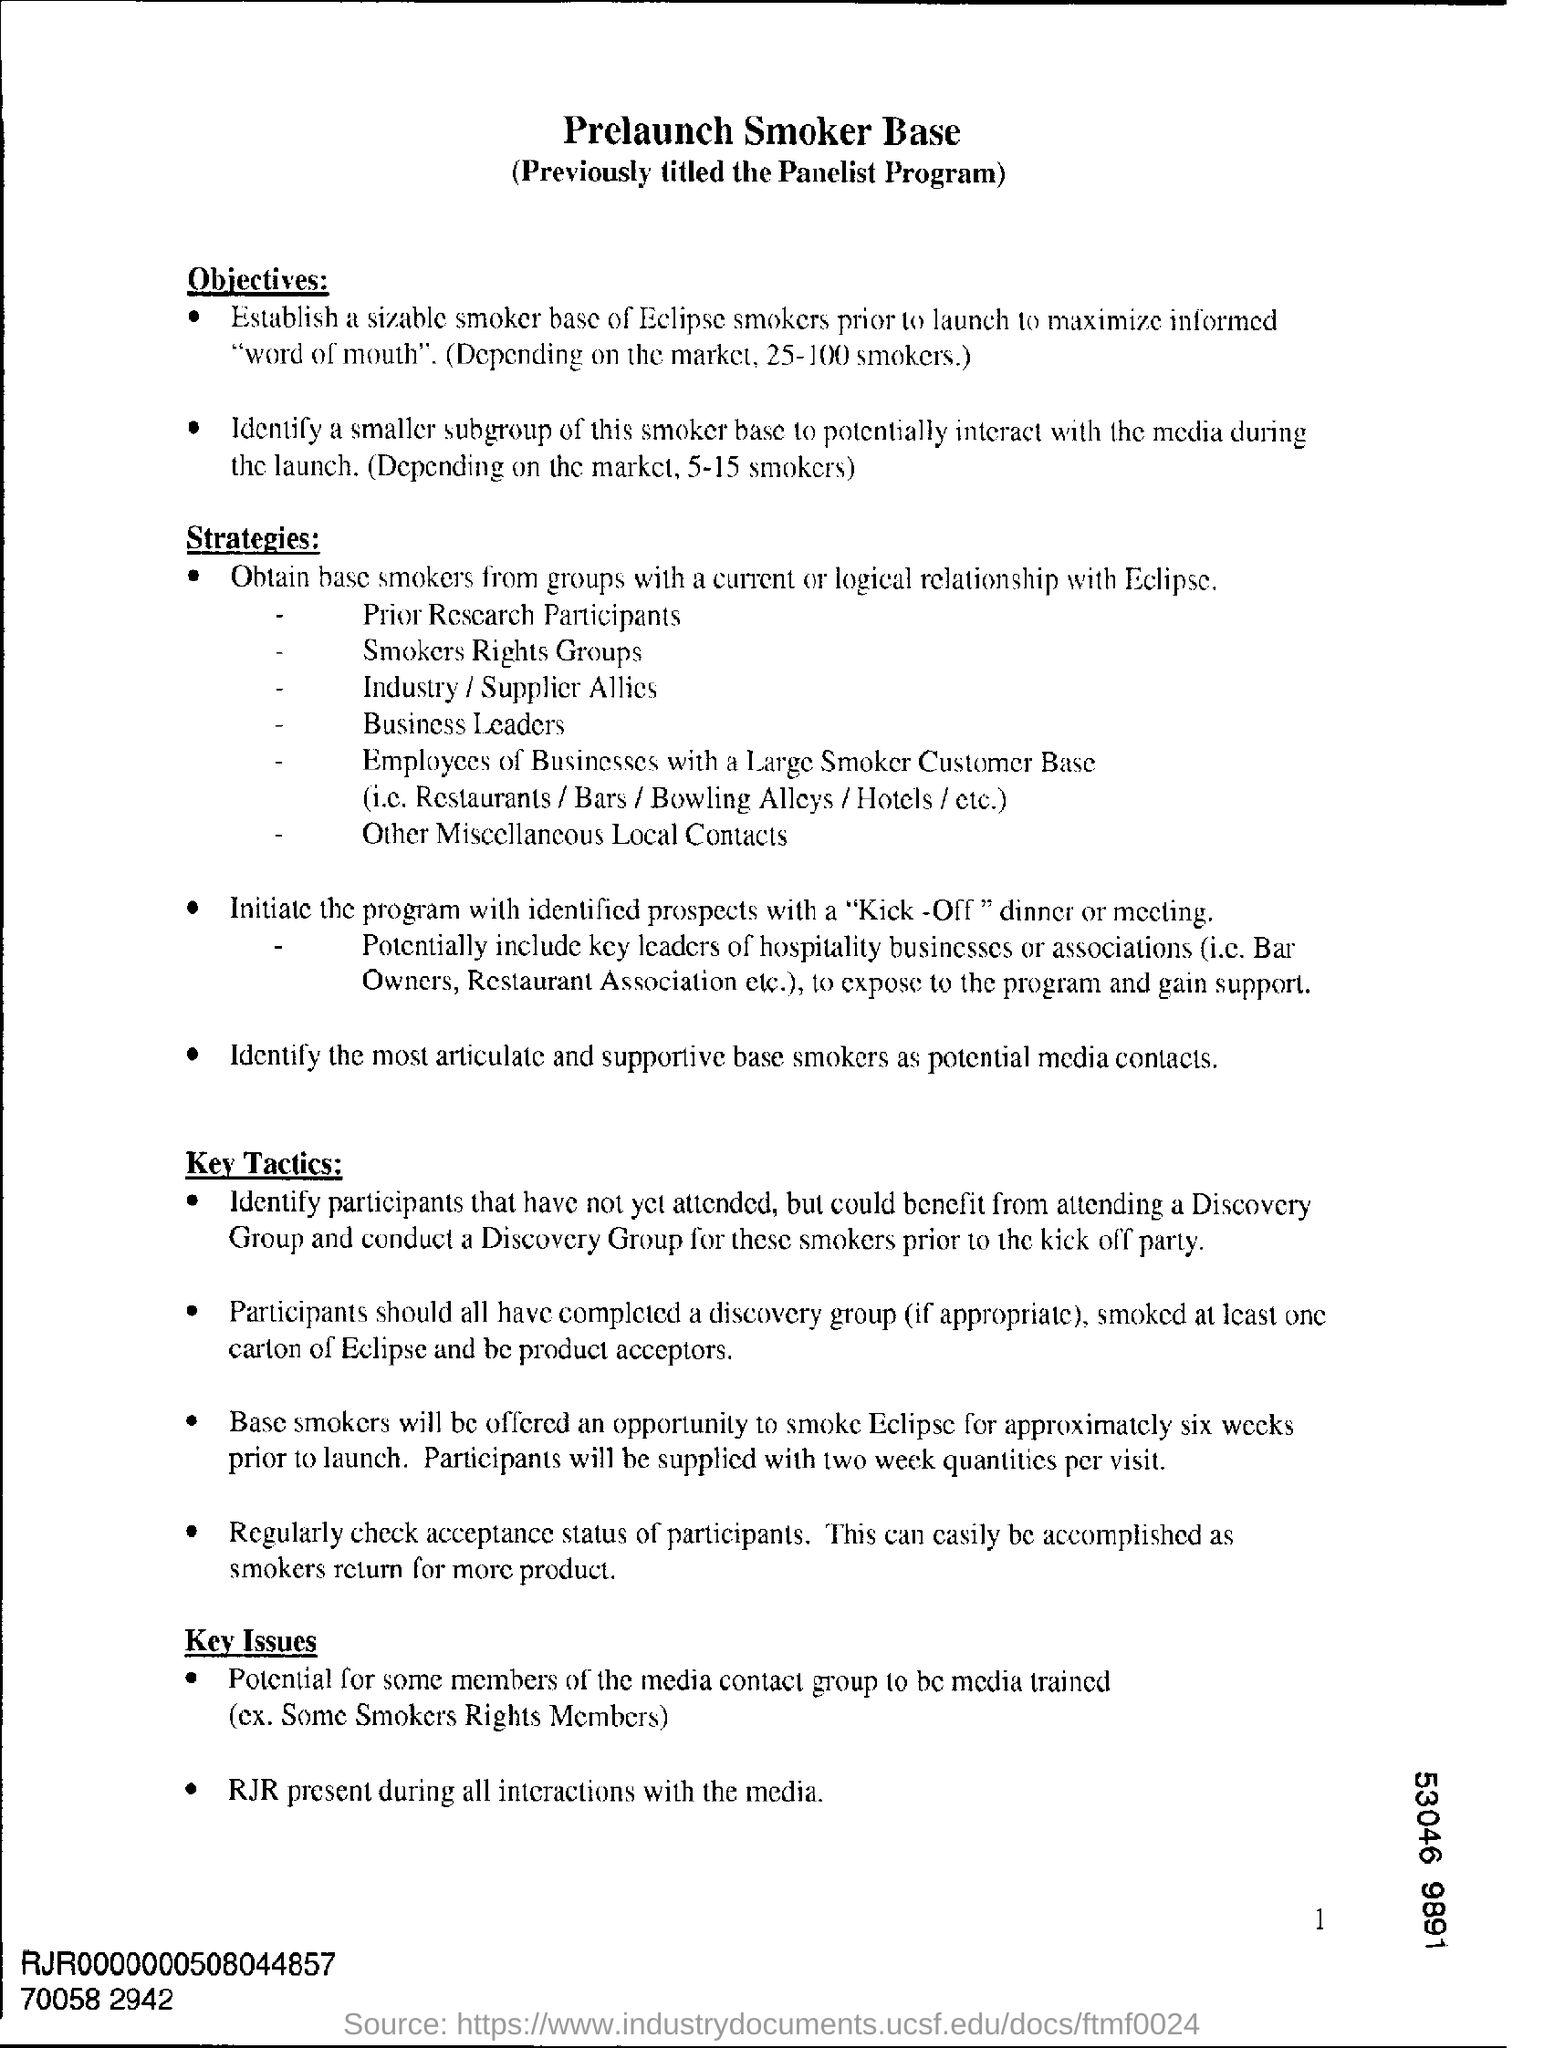Highlight a few significant elements in this photo. The heading at the top of the page is 'Prelaunch Smoker Base.' 